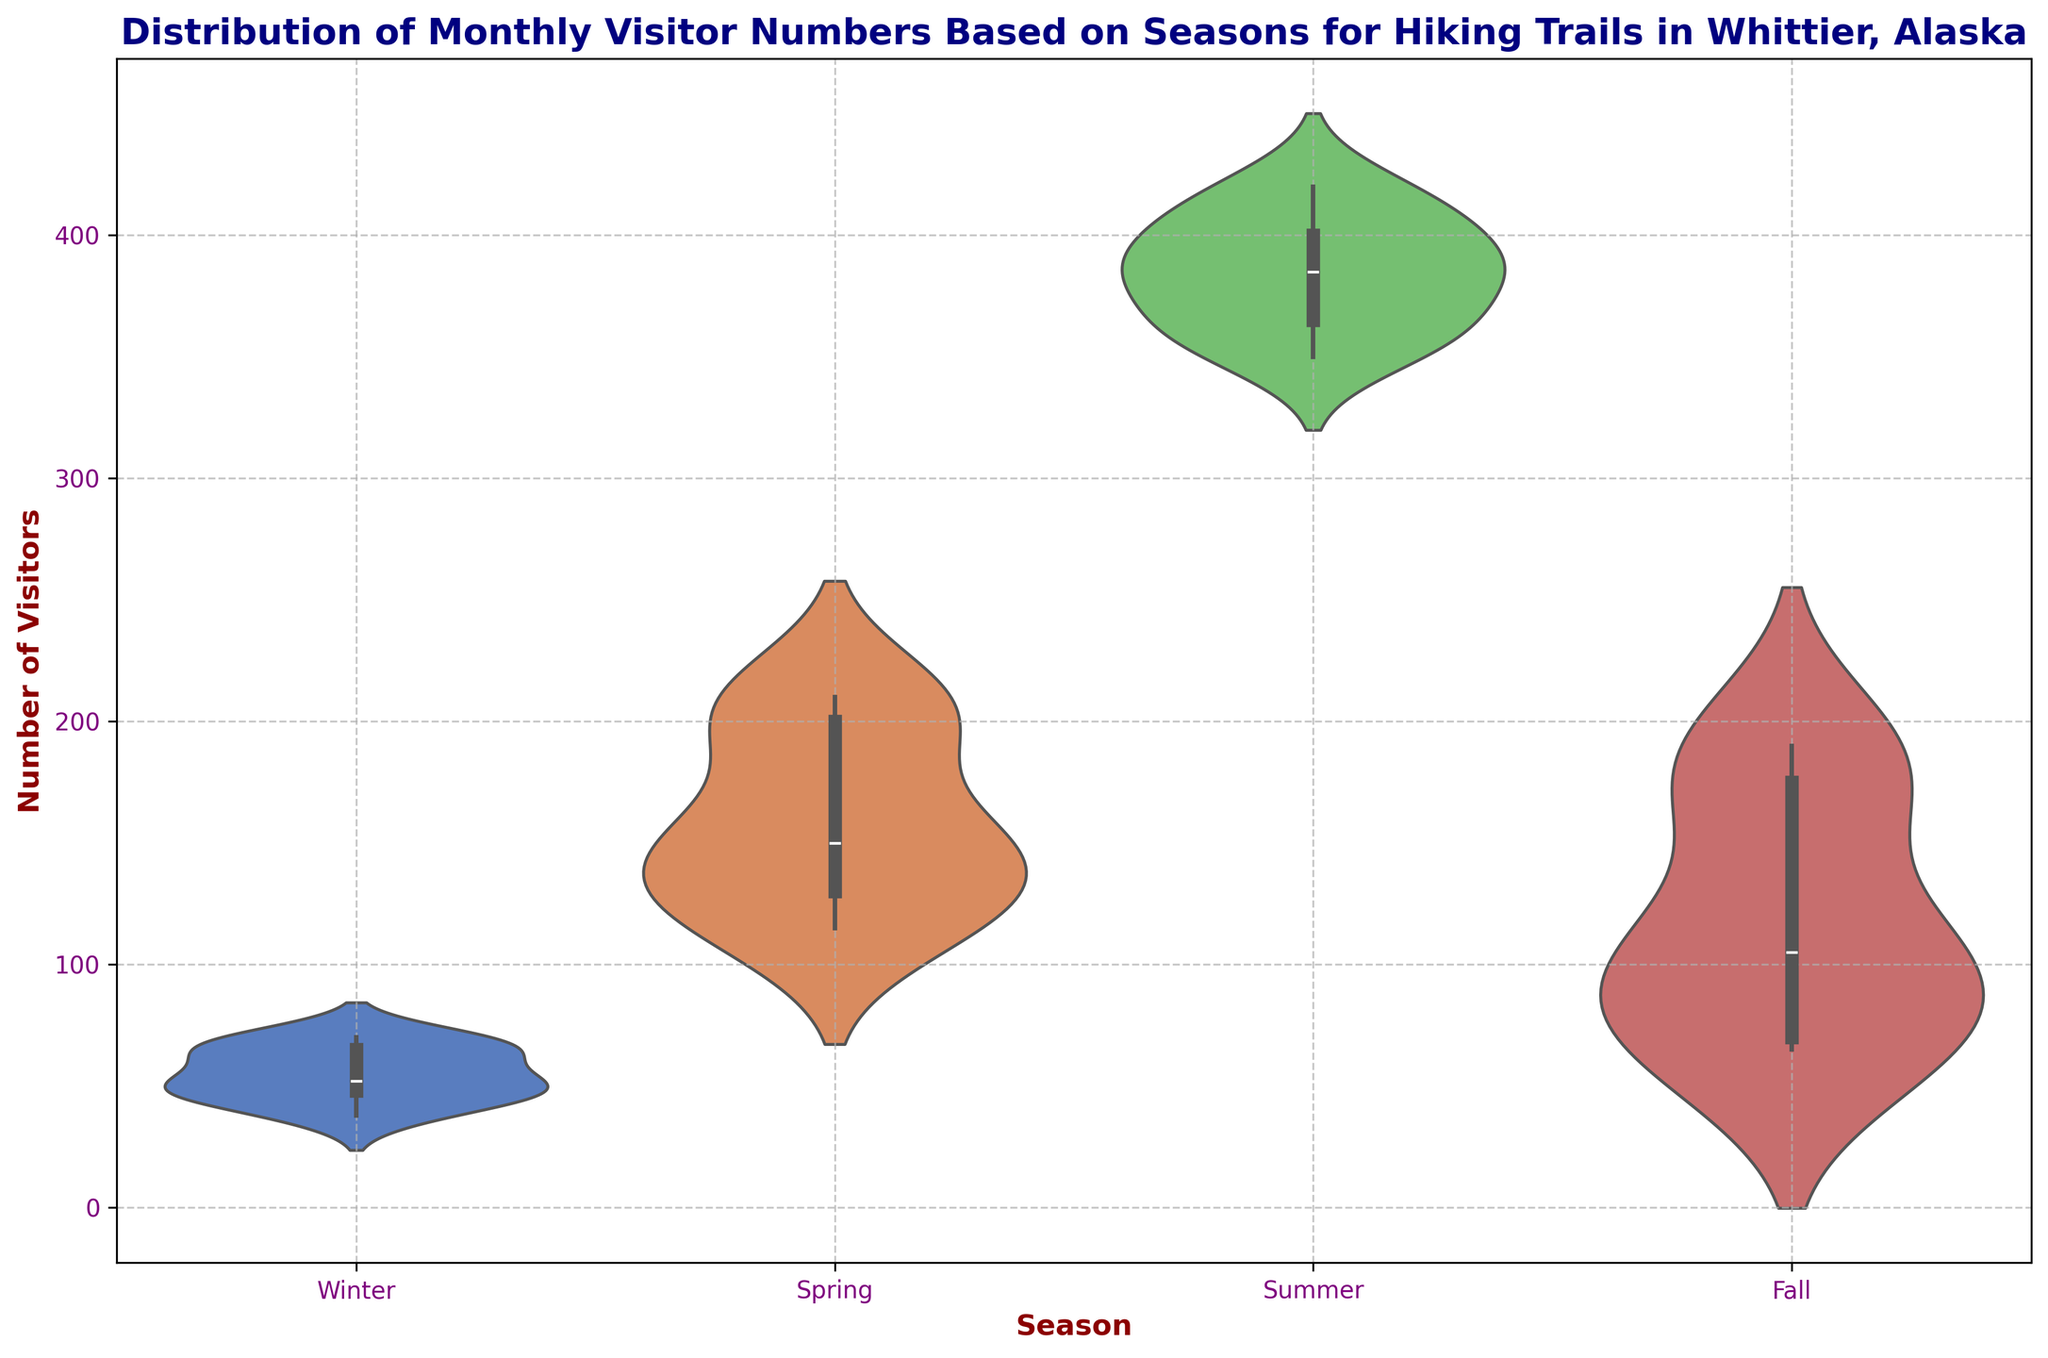What season has the widest range of visitor numbers? To determine the season with the widest range, look for the season with the largest vertical spread in its violin plot.
Answer: Summer How do the visitor numbers in Winter compare to those in Summer? Compare the vertical spread and central tendency of the violin plots for Winter and Summer. Winter has fewer visitors with a lower spread, while Summer has more visitors with a higher spread.
Answer: Winter has fewer visitors with a lower spread compared to Summer During which season is the median number of visitors the lowest? To find the lowest median, look at the central bulge and find the one that is lower for all seasons.
Answer: Winter Which season shows the highest peak in visitor numbers? Identify the season with the highest point on the y-axis in the violin plot.
Answer: Summer Which season has the most consistent visitor numbers (least variability)? Look for the season whose violin plot is the narrowest, indicating less variability in visitor numbers.
Answer: Winter What is the approximate median number of visitors in Spring? Observe the central point or central bulge in the violin plot for Spring.
Answer: Around 150-200 What seasonal month shows the largest increase in visitor numbers from the previous month? Identify the months with the most significant vertical difference between consecutive months across different seasons.
Answer: Spring (from March to April) How does visitor variability in Fall compare to that in Spring? Compare the spread (width) of the violin plots for Fall and Spring. Fall has a narrower spread compared to Spring.
Answer: Fall has less variability compared to Spring Which season has the highest minimum number of visitors? Find the lowest point on the violin plot for each season and compare them.
Answer: Summer 